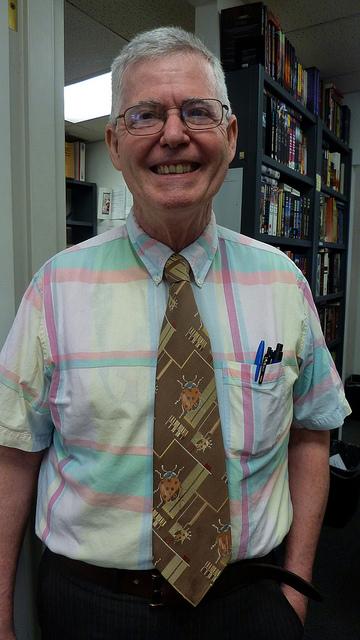Is this man crazy?
Give a very brief answer. No. How many ties is this man wearing?
Answer briefly. 1. Is the man wearing one tie?
Give a very brief answer. Yes. Did this man shave this morning?
Write a very short answer. Yes. Are these real ties?
Quick response, please. Yes. What is on the man's neck?
Write a very short answer. Tie. What pattern is his shirt?
Concise answer only. Plaid. What color is the tie?
Give a very brief answer. Brown. Is the shirt checkered?
Quick response, please. Yes. Is the man happy or annoyed?
Give a very brief answer. Happy. What insect is on the man's tie?
Write a very short answer. Ladybug. How many pockets does the man's shirt have?
Be succinct. 1. See any pens?
Write a very short answer. Yes. What shapes are on the tie?
Answer briefly. Squares. 